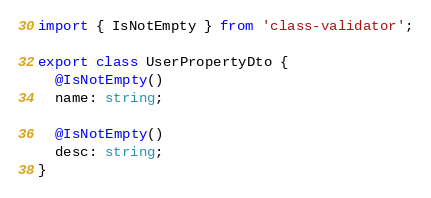Convert code to text. <code><loc_0><loc_0><loc_500><loc_500><_TypeScript_>import { IsNotEmpty } from 'class-validator';

export class UserPropertyDto {
  @IsNotEmpty()
  name: string;

  @IsNotEmpty()
  desc: string;
}
</code> 